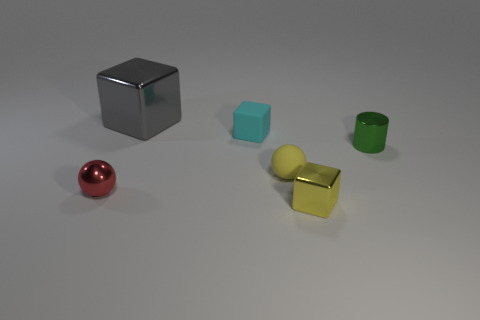Subtract all small yellow shiny cubes. How many cubes are left? 2 Add 3 tiny red things. How many objects exist? 9 Subtract all balls. How many objects are left? 4 Subtract all yellow balls. How many balls are left? 1 Subtract 2 blocks. How many blocks are left? 1 Subtract 0 green spheres. How many objects are left? 6 Subtract all brown blocks. Subtract all green spheres. How many blocks are left? 3 Subtract all green cylinders. How many cyan blocks are left? 1 Subtract all tiny rubber cubes. Subtract all small yellow cubes. How many objects are left? 4 Add 4 gray objects. How many gray objects are left? 5 